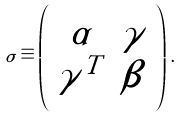<formula> <loc_0><loc_0><loc_500><loc_500>\sigma \equiv \left ( \begin{array} { c c } \alpha & \gamma \\ \gamma ^ { T } & \beta \end{array} \right ) \, .</formula> 